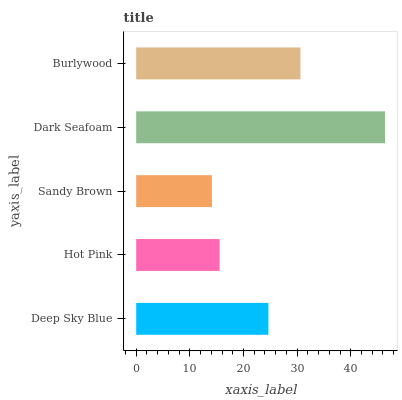Is Sandy Brown the minimum?
Answer yes or no. Yes. Is Dark Seafoam the maximum?
Answer yes or no. Yes. Is Hot Pink the minimum?
Answer yes or no. No. Is Hot Pink the maximum?
Answer yes or no. No. Is Deep Sky Blue greater than Hot Pink?
Answer yes or no. Yes. Is Hot Pink less than Deep Sky Blue?
Answer yes or no. Yes. Is Hot Pink greater than Deep Sky Blue?
Answer yes or no. No. Is Deep Sky Blue less than Hot Pink?
Answer yes or no. No. Is Deep Sky Blue the high median?
Answer yes or no. Yes. Is Deep Sky Blue the low median?
Answer yes or no. Yes. Is Hot Pink the high median?
Answer yes or no. No. Is Burlywood the low median?
Answer yes or no. No. 